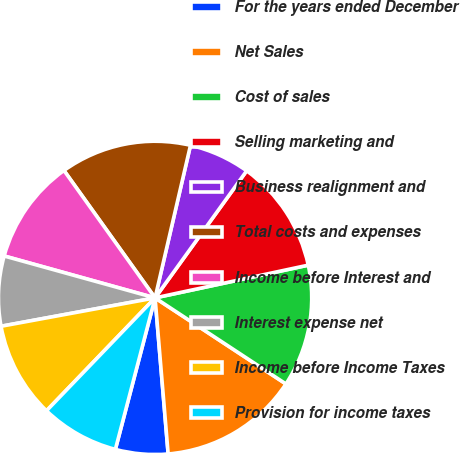Convert chart to OTSL. <chart><loc_0><loc_0><loc_500><loc_500><pie_chart><fcel>For the years ended December<fcel>Net Sales<fcel>Cost of sales<fcel>Selling marketing and<fcel>Business realignment and<fcel>Total costs and expenses<fcel>Income before Interest and<fcel>Interest expense net<fcel>Income before Income Taxes<fcel>Provision for income taxes<nl><fcel>5.41%<fcel>14.41%<fcel>12.61%<fcel>11.71%<fcel>6.31%<fcel>13.51%<fcel>10.81%<fcel>7.21%<fcel>9.91%<fcel>8.11%<nl></chart> 